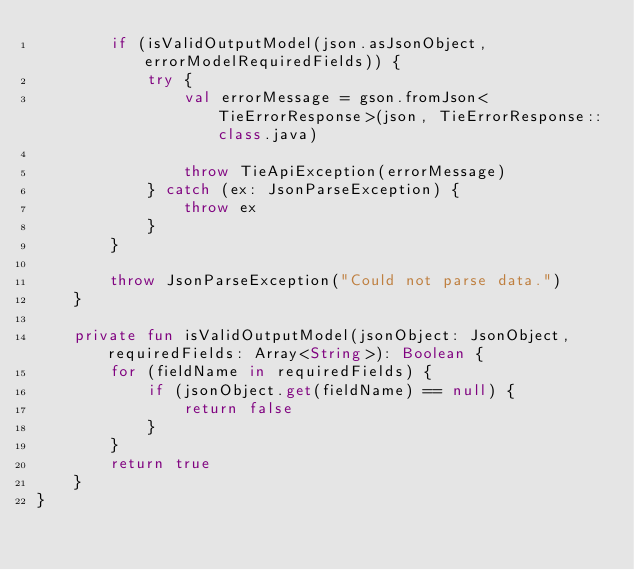<code> <loc_0><loc_0><loc_500><loc_500><_Kotlin_>        if (isValidOutputModel(json.asJsonObject, errorModelRequiredFields)) {
            try {
                val errorMessage = gson.fromJson<TieErrorResponse>(json, TieErrorResponse::class.java)

                throw TieApiException(errorMessage)
            } catch (ex: JsonParseException) {
                throw ex
            }
        }

        throw JsonParseException("Could not parse data.")
    }

    private fun isValidOutputModel(jsonObject: JsonObject, requiredFields: Array<String>): Boolean {
        for (fieldName in requiredFields) {
            if (jsonObject.get(fieldName) == null) {
                return false
            }
        }
        return true
    }
}

</code> 